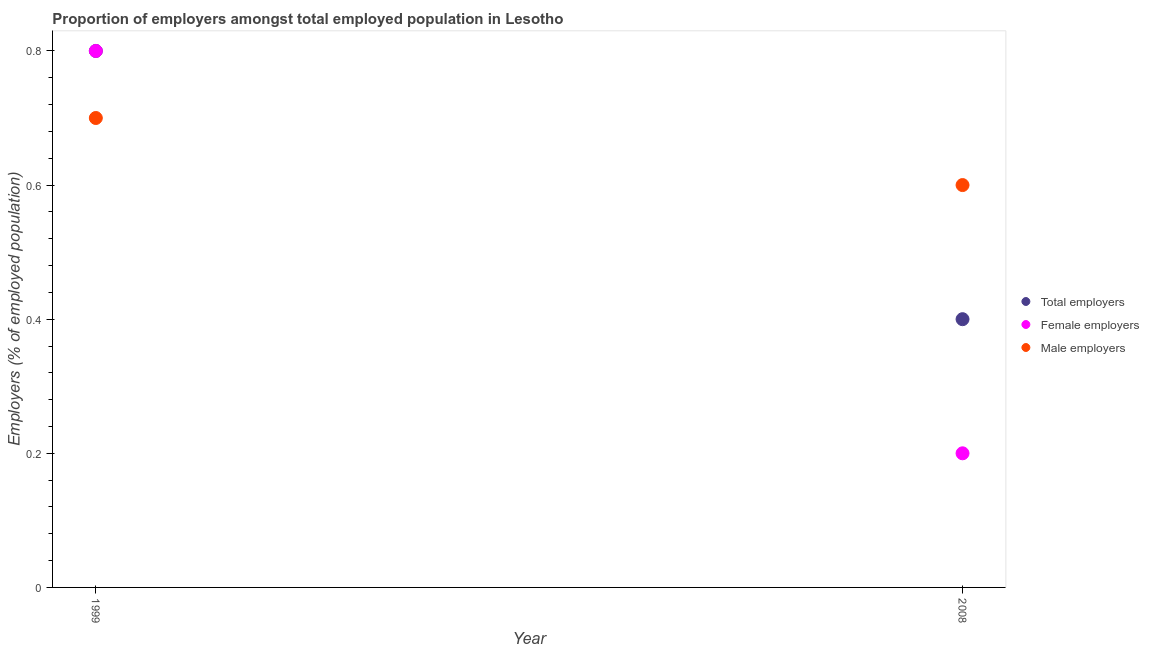What is the percentage of male employers in 1999?
Offer a terse response. 0.7. Across all years, what is the maximum percentage of total employers?
Offer a terse response. 0.8. Across all years, what is the minimum percentage of male employers?
Make the answer very short. 0.6. In which year was the percentage of male employers minimum?
Provide a short and direct response. 2008. What is the total percentage of total employers in the graph?
Your response must be concise. 1.2. What is the difference between the percentage of male employers in 1999 and that in 2008?
Provide a succinct answer. 0.1. What is the difference between the percentage of female employers in 1999 and the percentage of male employers in 2008?
Offer a very short reply. 0.2. What is the average percentage of total employers per year?
Ensure brevity in your answer.  0.6. In the year 1999, what is the difference between the percentage of female employers and percentage of total employers?
Ensure brevity in your answer.  0. In how many years, is the percentage of female employers greater than 0.36 %?
Give a very brief answer. 1. Does the percentage of female employers monotonically increase over the years?
Your answer should be compact. No. How many dotlines are there?
Ensure brevity in your answer.  3. How many years are there in the graph?
Give a very brief answer. 2. What is the difference between two consecutive major ticks on the Y-axis?
Keep it short and to the point. 0.2. Does the graph contain any zero values?
Offer a terse response. No. Where does the legend appear in the graph?
Offer a very short reply. Center right. How are the legend labels stacked?
Keep it short and to the point. Vertical. What is the title of the graph?
Offer a terse response. Proportion of employers amongst total employed population in Lesotho. Does "Domestic economy" appear as one of the legend labels in the graph?
Provide a short and direct response. No. What is the label or title of the X-axis?
Offer a very short reply. Year. What is the label or title of the Y-axis?
Your answer should be very brief. Employers (% of employed population). What is the Employers (% of employed population) of Total employers in 1999?
Make the answer very short. 0.8. What is the Employers (% of employed population) of Female employers in 1999?
Offer a terse response. 0.8. What is the Employers (% of employed population) of Male employers in 1999?
Make the answer very short. 0.7. What is the Employers (% of employed population) in Total employers in 2008?
Offer a terse response. 0.4. What is the Employers (% of employed population) in Female employers in 2008?
Your response must be concise. 0.2. What is the Employers (% of employed population) in Male employers in 2008?
Offer a terse response. 0.6. Across all years, what is the maximum Employers (% of employed population) of Total employers?
Make the answer very short. 0.8. Across all years, what is the maximum Employers (% of employed population) of Female employers?
Ensure brevity in your answer.  0.8. Across all years, what is the maximum Employers (% of employed population) in Male employers?
Offer a terse response. 0.7. Across all years, what is the minimum Employers (% of employed population) in Total employers?
Your answer should be compact. 0.4. Across all years, what is the minimum Employers (% of employed population) of Female employers?
Offer a terse response. 0.2. Across all years, what is the minimum Employers (% of employed population) of Male employers?
Provide a short and direct response. 0.6. What is the total Employers (% of employed population) in Female employers in the graph?
Make the answer very short. 1. What is the difference between the Employers (% of employed population) in Total employers in 1999 and the Employers (% of employed population) in Male employers in 2008?
Provide a succinct answer. 0.2. What is the average Employers (% of employed population) of Male employers per year?
Ensure brevity in your answer.  0.65. In the year 1999, what is the difference between the Employers (% of employed population) of Total employers and Employers (% of employed population) of Male employers?
Your response must be concise. 0.1. In the year 2008, what is the difference between the Employers (% of employed population) of Female employers and Employers (% of employed population) of Male employers?
Give a very brief answer. -0.4. What is the ratio of the Employers (% of employed population) of Total employers in 1999 to that in 2008?
Your answer should be very brief. 2. What is the difference between the highest and the lowest Employers (% of employed population) in Total employers?
Your response must be concise. 0.4. What is the difference between the highest and the lowest Employers (% of employed population) in Female employers?
Give a very brief answer. 0.6. 